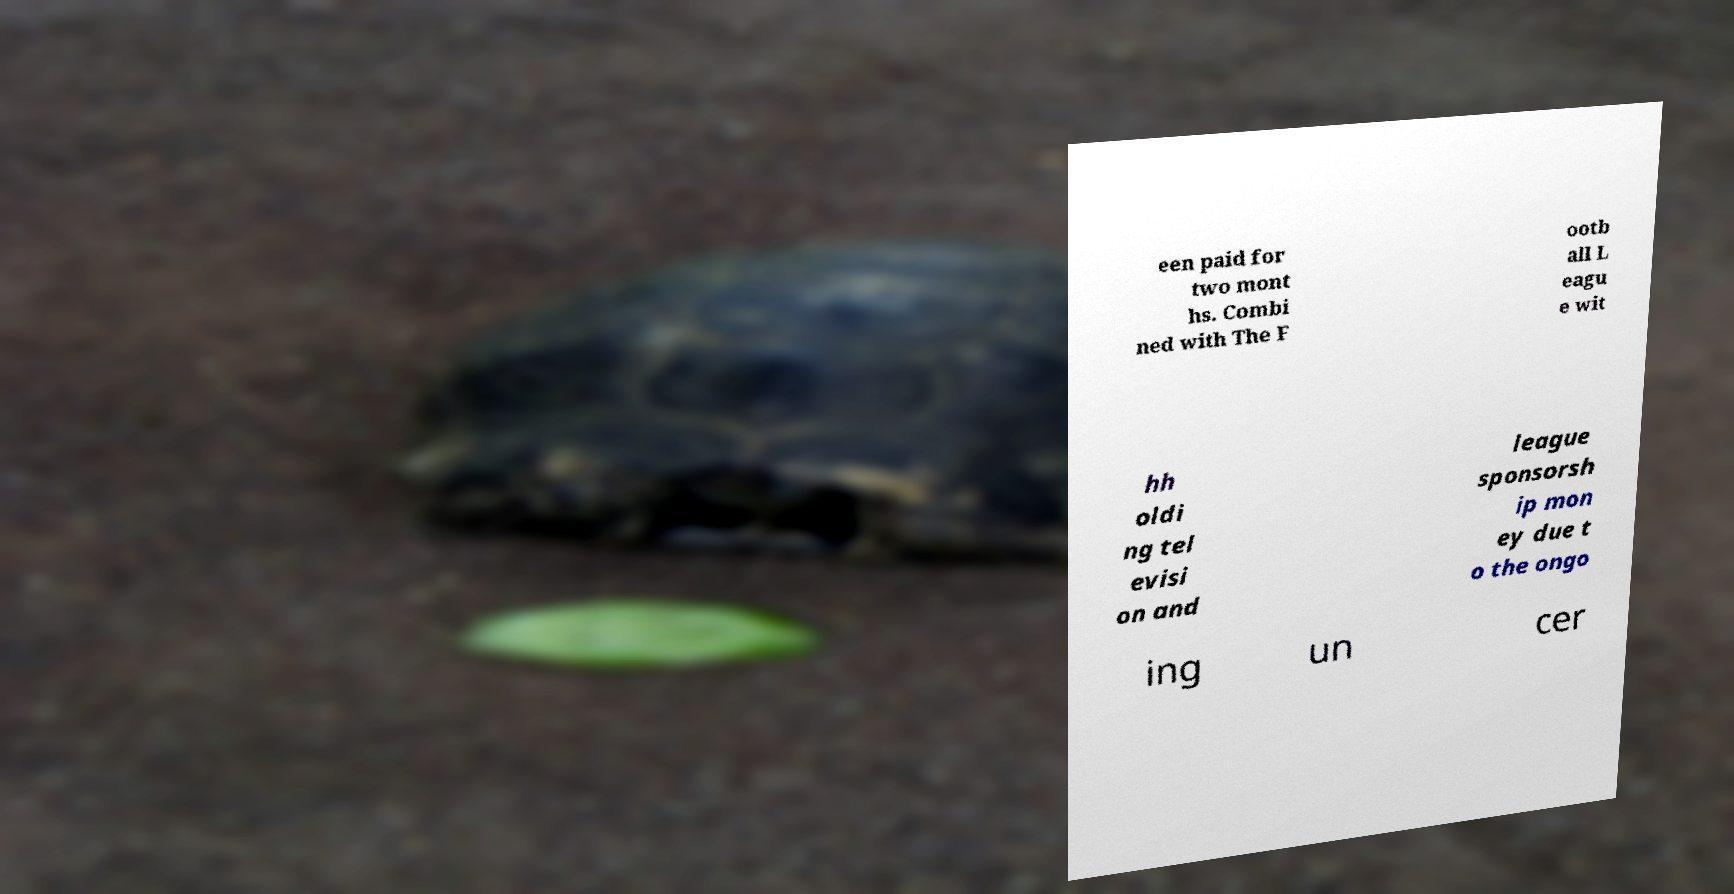Please identify and transcribe the text found in this image. een paid for two mont hs. Combi ned with The F ootb all L eagu e wit hh oldi ng tel evisi on and league sponsorsh ip mon ey due t o the ongo ing un cer 